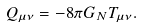Convert formula to latex. <formula><loc_0><loc_0><loc_500><loc_500>Q _ { \mu \nu } = - 8 \pi G _ { N } T _ { \mu \nu } .</formula> 